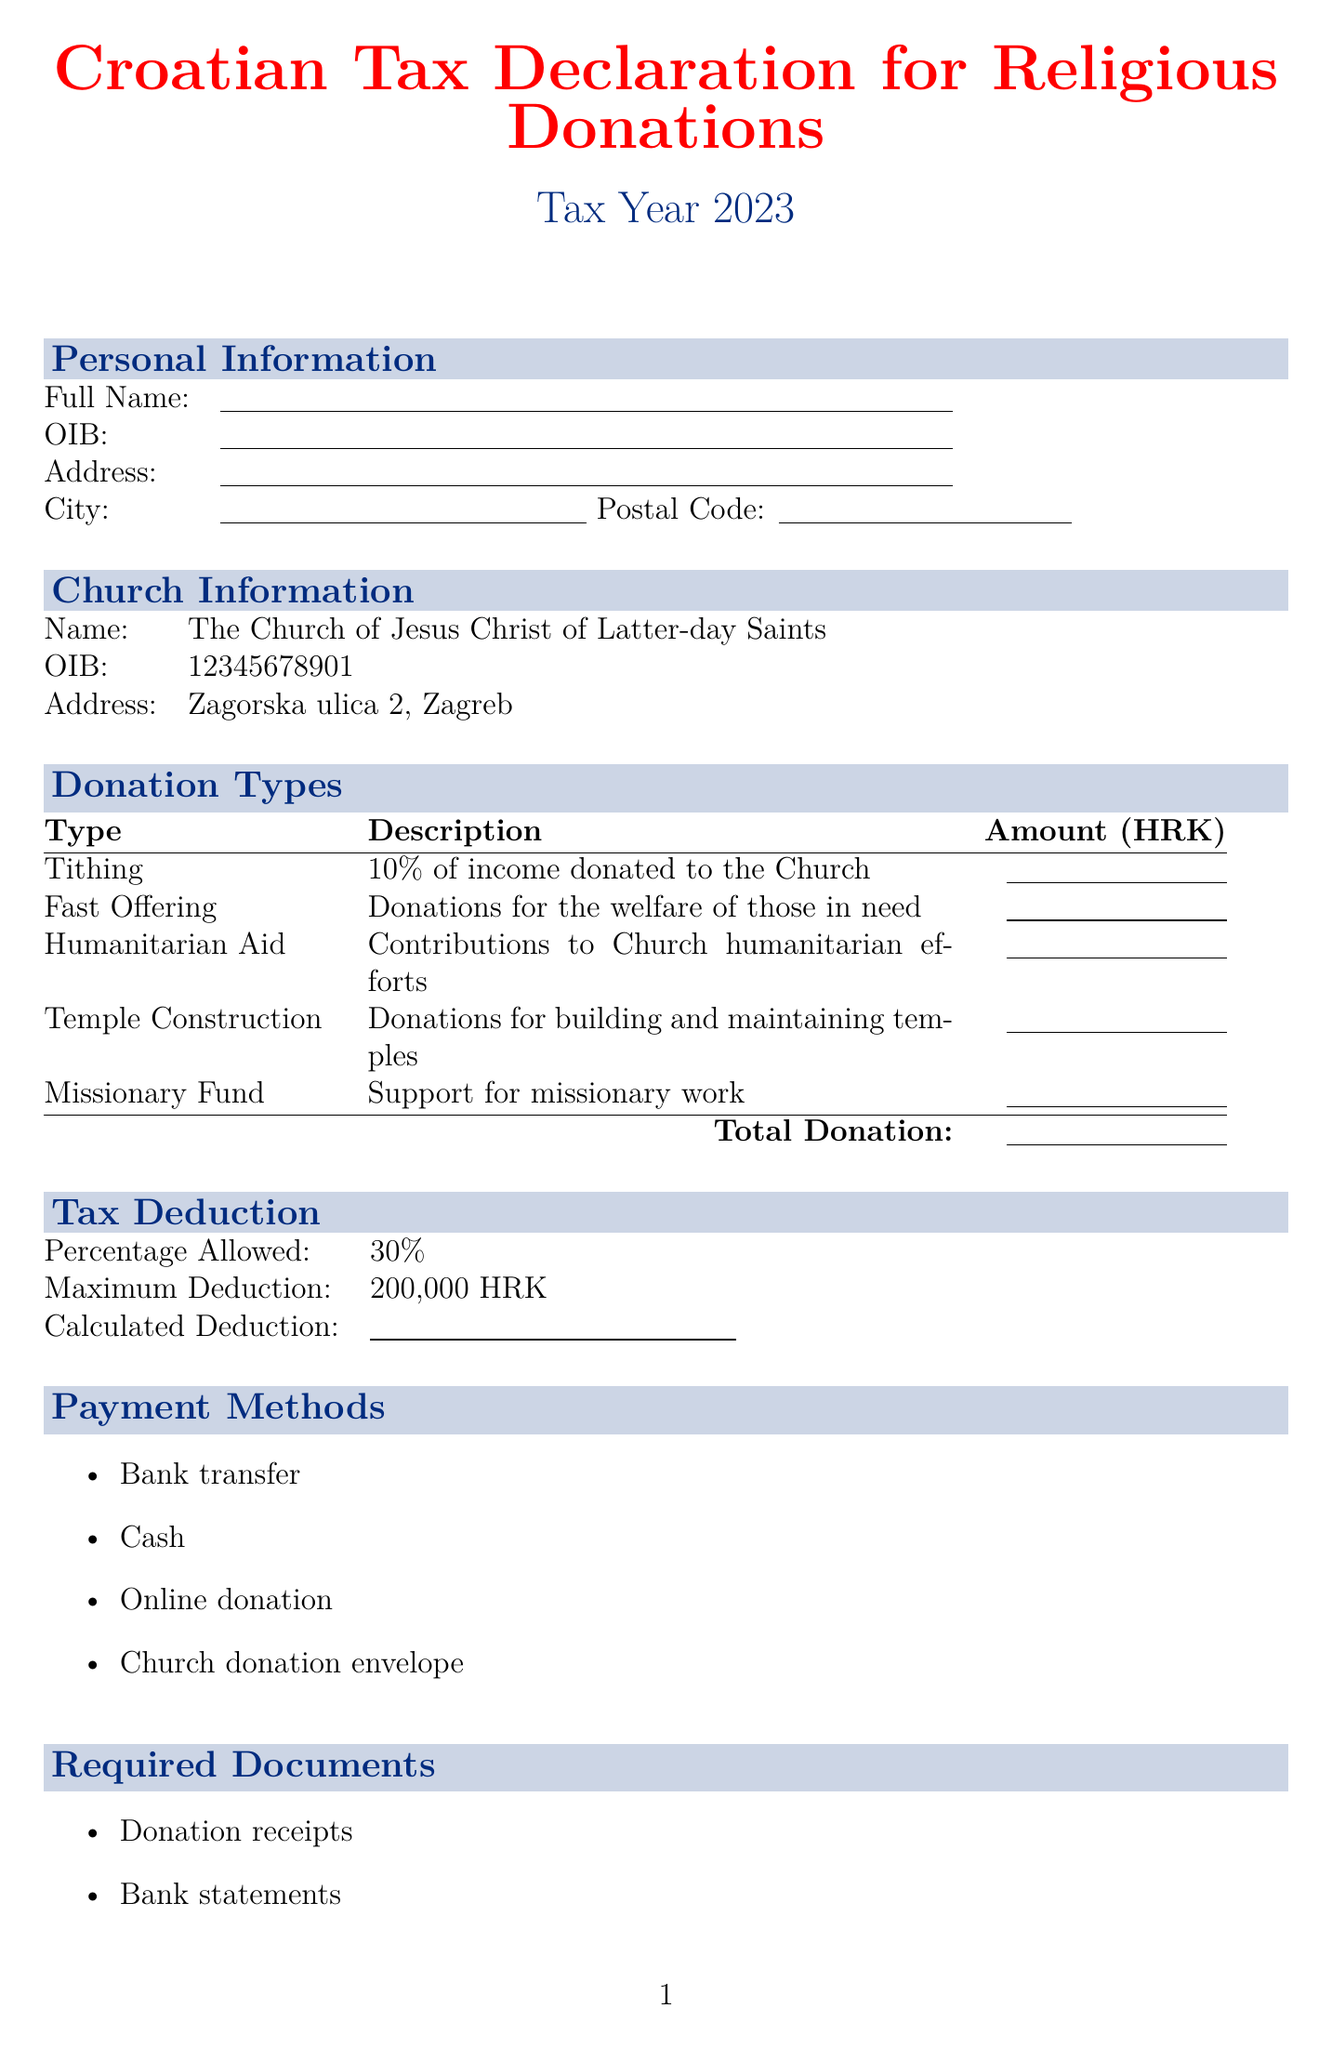what is the tax year for this declaration? The tax year is specified in the document under "Tax Year," indicating the relevant year for the declaration.
Answer: 2023 what is the maximum deduction allowed? The maximum deduction is mentioned under the "Tax Deduction" section, indicating how much can be deducted from taxable income.
Answer: 200,000 HRK who is the church associated with this form? The church's name is listed clearly in the document under "Church Information."
Answer: The Church of Jesus Christ of Latter-day Saints what percentage of donations is allowed for deduction? This percentage is specified within the "Tax Deduction" section as part of the information on allowable deductions for religious donations.
Answer: 30% when is the submission deadline for the declaration? The submission deadline is explicitly stated in the "Submission Information" section as the date by which the declaration must be submitted.
Answer: February 28, 2024 what are the payment methods listed? Payment methods are listed as a bullet-point format, providing options available for making donations.
Answer: Bank transfer, Cash, Online donation, Church donation envelope which documents are required for the submission? The required documents section lists the necessary documentation that must accompany the declaration for it to be processed.
Answer: Donation receipts, Bank statements, Church-issued donation summary what needs to be kept for at least 5 years? The additional notes section includes a reminder about the importance of retaining specific documents over a period of time for record-keeping purposes.
Answer: All original receipts 